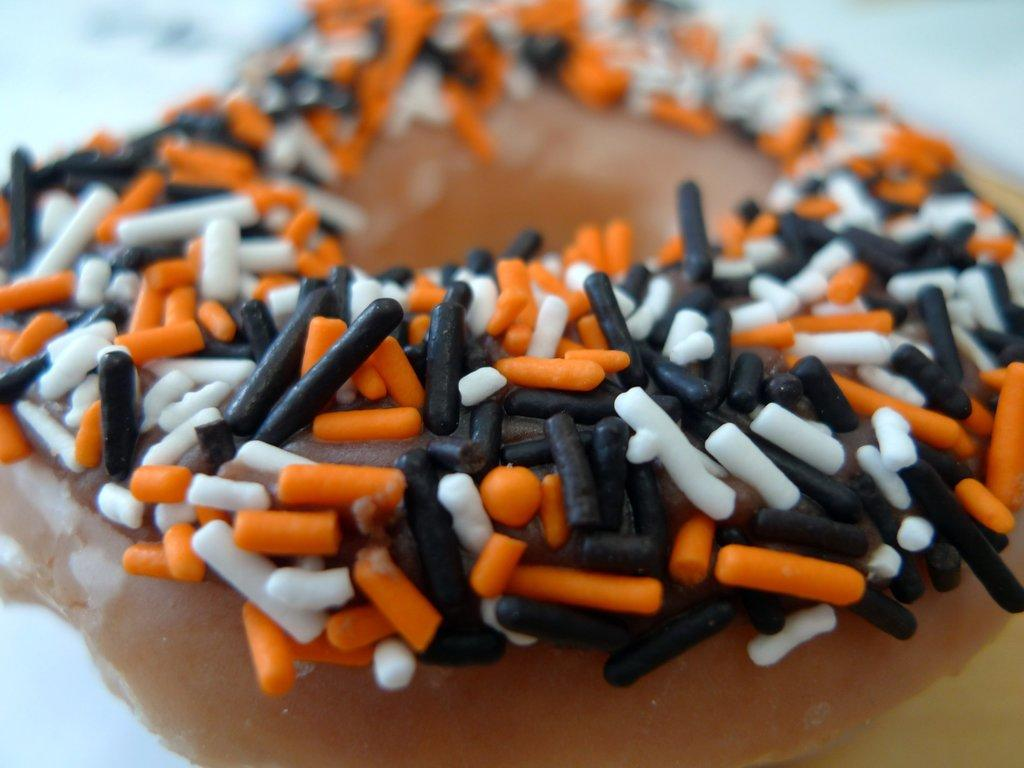What type of food is the main subject of the image? There is a doughnut in the image. What is added to the doughnut as a decoration or topping? Candy corns are present on the doughnut. What type of butter is spread on the doughnut in the image? There is no butter present on the doughnut in the image; it is decorated with candy corns. 